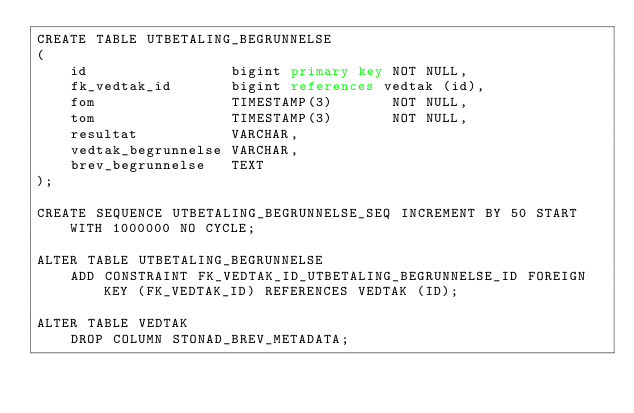Convert code to text. <code><loc_0><loc_0><loc_500><loc_500><_SQL_>CREATE TABLE UTBETALING_BEGRUNNELSE
(
    id                 bigint primary key NOT NULL,
    fk_vedtak_id       bigint references vedtak (id),
    fom                TIMESTAMP(3)       NOT NULL,
    tom                TIMESTAMP(3)       NOT NULL,
    resultat           VARCHAR,
    vedtak_begrunnelse VARCHAR,
    brev_begrunnelse   TEXT
);

CREATE SEQUENCE UTBETALING_BEGRUNNELSE_SEQ INCREMENT BY 50 START WITH 1000000 NO CYCLE;

ALTER TABLE UTBETALING_BEGRUNNELSE
    ADD CONSTRAINT FK_VEDTAK_ID_UTBETALING_BEGRUNNELSE_ID FOREIGN KEY (FK_VEDTAK_ID) REFERENCES VEDTAK (ID);

ALTER TABLE VEDTAK
    DROP COLUMN STONAD_BREV_METADATA;</code> 